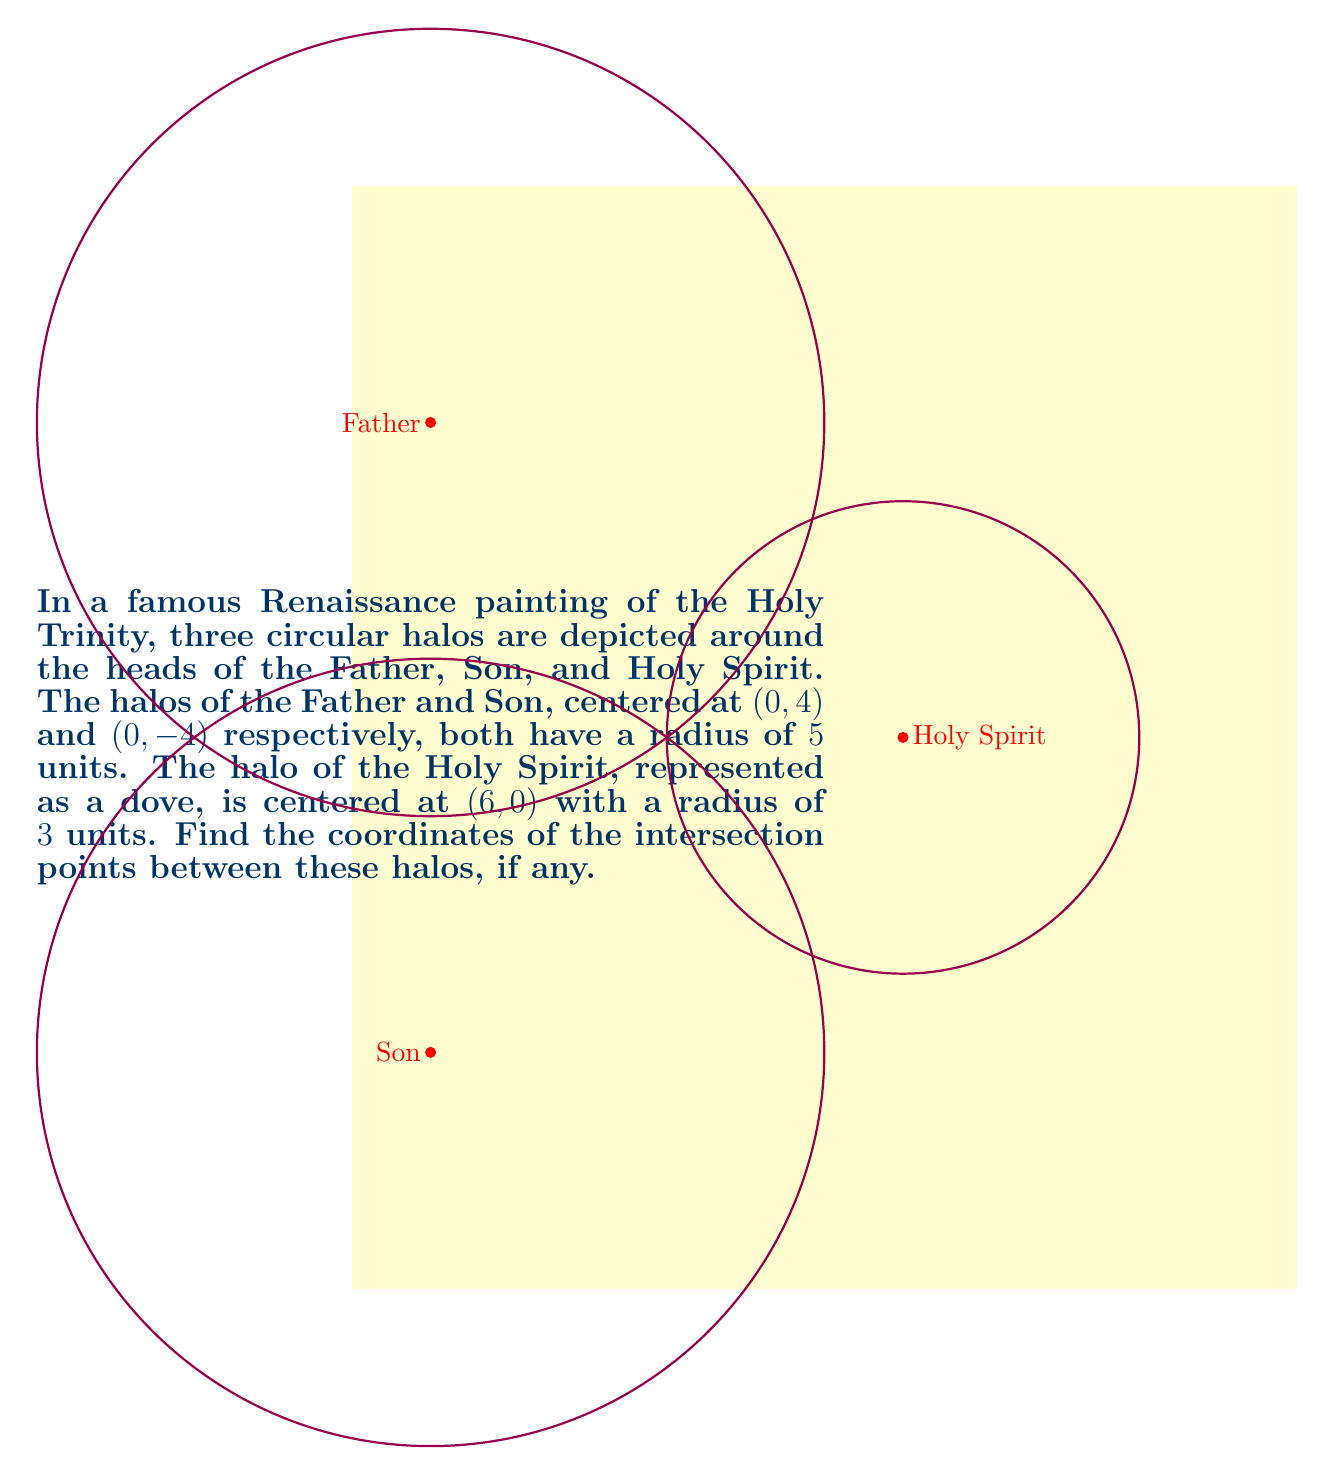What is the answer to this math problem? Let's approach this step-by-step:

1) First, we need to write the equations of the three circles:

   Father's halo: $$(x-0)^2 + (y-4)^2 = 5^2$$
   Son's halo: $$(x-0)^2 + (y+4)^2 = 5^2$$
   Holy Spirit's halo: $$(x-6)^2 + (y-0)^2 = 3^2$$

2) To find the intersections, we need to solve these equations in pairs:

3) For the Father's and Son's halos:
   $$(x-0)^2 + (y-4)^2 = 25$$ and $$(x-0)^2 + (y+4)^2 = 25$$
   Subtracting these equations:
   $$(y-4)^2 - (y+4)^2 = 0$$
   $$y^2-8y+16 - (y^2+8y+16) = 0$$
   $$-16y = 0$$
   $$y = 0$$
   Substituting this back:
   $$x^2 + 0^2 = 25$$
   $$x = \pm 5$$
   So, these intersect at (5, 0) and (-5, 0).

4) For the Father's halo and Holy Spirit's halo:
   $$(x-0)^2 + (y-4)^2 = 25$$ and $$(x-6)^2 + y^2 = 9$$
   Expanding and subtracting:
   $$x^2 + y^2 - 8y + 16 - (x^2-12x+36+y^2) = 25 - 9$$
   $$12x - 8y - 20 = 16$$
   $$3x - 2y = 9$$
   Substituting this into the equation of the Holy Spirit's halo:
   $$(x-6)^2 + (\frac{3x-9}{2})^2 = 9$$
   Solving this quadratic equation gives:
   $$x \approx 7.4641$$ and $$y \approx 5.1962$$

5) For the Son's halo and Holy Spirit's halo:
   Similar to step 4, we get:
   $$x \approx 7.4641$$ and $$y \approx -5.1962$$

6) The Father's and Son's halos intersect with each other, but neither intersects with the Holy Spirit's halo (the calculated points are not on the Holy Spirit's halo).
Answer: (-5, 0) and (5, 0) 